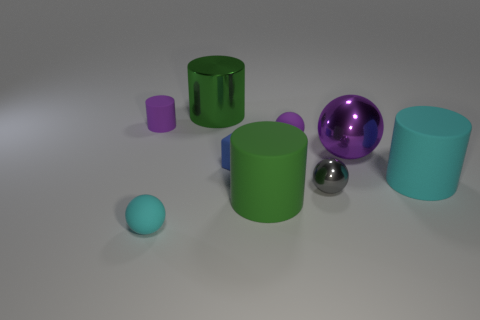Is the shape of the purple metallic thing the same as the small gray metallic object?
Your response must be concise. Yes. What is the material of the purple thing that is the same shape as the large green rubber thing?
Your answer should be compact. Rubber. Do the purple cylinder and the tiny purple thing in front of the tiny purple rubber cylinder have the same material?
Offer a terse response. Yes. What size is the other sphere that is the same material as the tiny purple ball?
Give a very brief answer. Small. How big is the green thing that is behind the big green rubber cylinder?
Your answer should be compact. Large. What number of rubber cylinders are the same size as the green shiny cylinder?
Offer a very short reply. 2. There is another rubber ball that is the same color as the large sphere; what size is it?
Your response must be concise. Small. Is there another rubber ball that has the same color as the big sphere?
Your answer should be very brief. Yes. What is the color of the metal cylinder that is the same size as the purple metal thing?
Provide a short and direct response. Green. There is a metallic cylinder; does it have the same color as the cylinder in front of the large cyan matte cylinder?
Make the answer very short. Yes. 